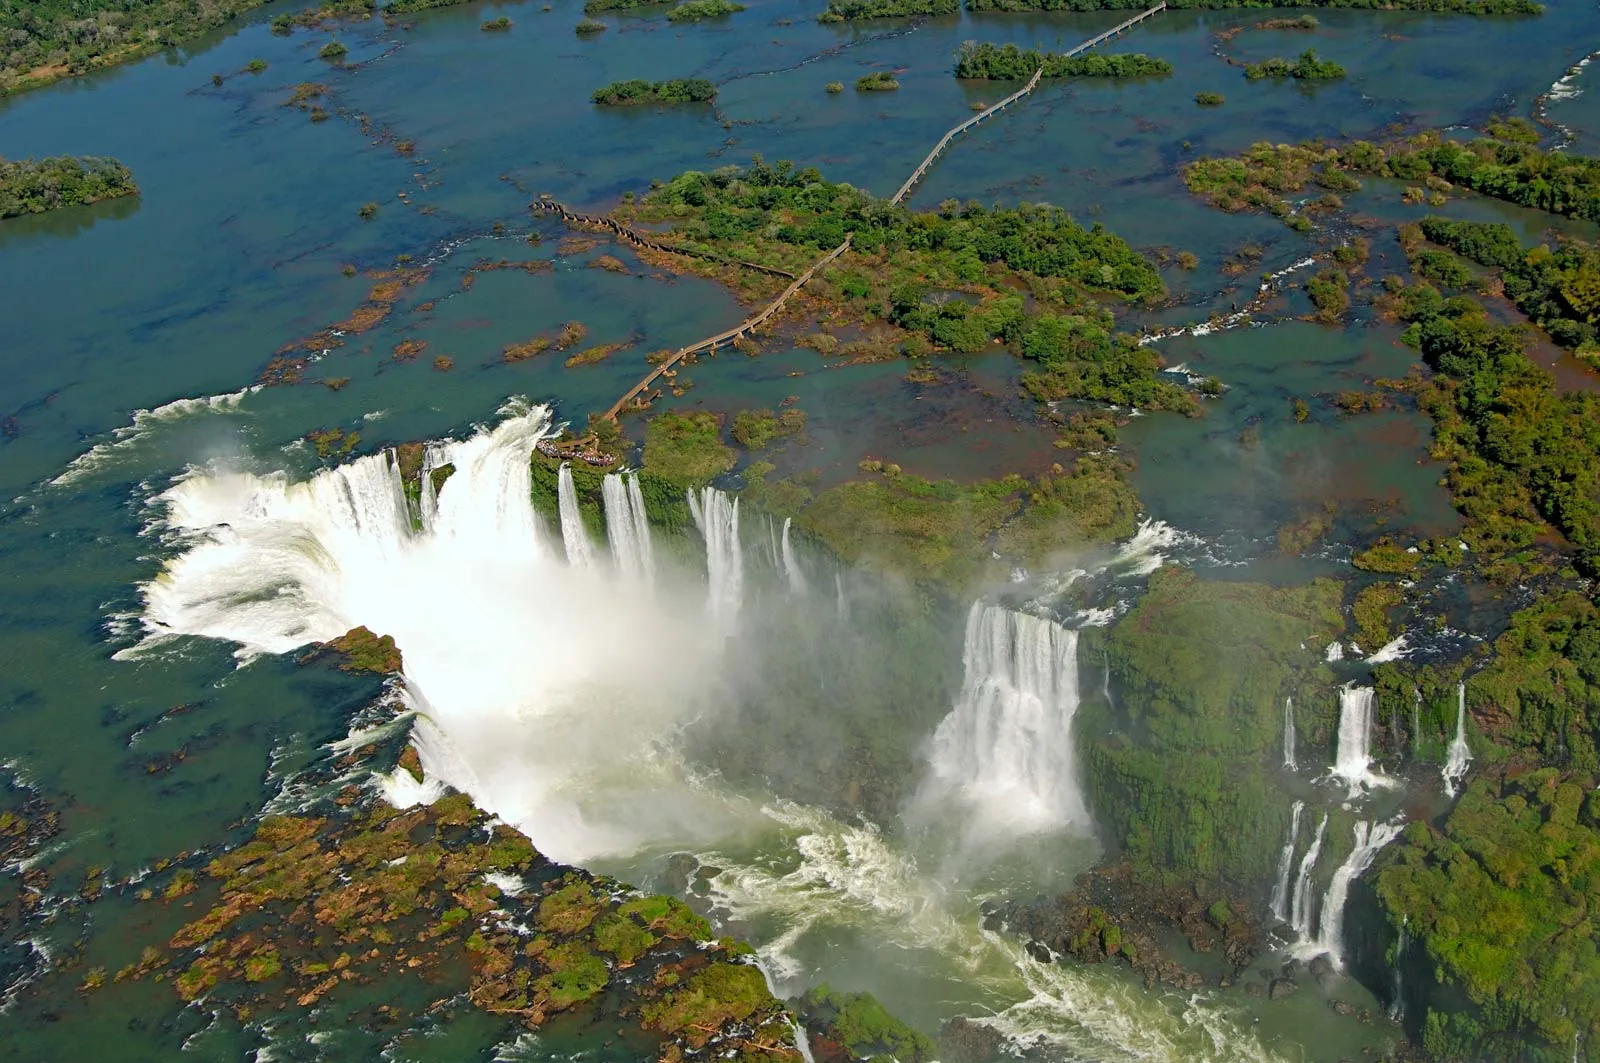What details stand out in this picture? From this vantage point, the Iguazu Falls stand out as the most prominent feature, with the water violently plunging down the cliffs and turning into a frothy white that contrasts beautifully with the calm surrounding waters. The lush greenery adds a splash of vibrant color, with the forest bordering the falls providing a sense of depth and richness. Additionally, one can notice the intricate network of wooden walkways allowing visitors to get closer to the falls—a testament to human ingenuity harmonizing with nature. What might one feel standing so close to the edge of the falls? Standing close to the edge of Iguazu Falls would be an overwhelming experience. The sheer force and sound of the water crashing down would fill one with awe and a sense of the power of nature. The mist from the falls would brush against your skin, creating a refreshing and ethereal atmosphere. There would likely be a mix of excitement and a touch of fear, knowing the immense volume of water and its unstoppable energy. Overall, it would be a humbling and exhilarating experience. 